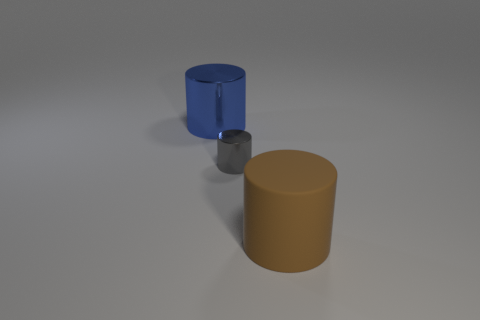Subtract all big cylinders. How many cylinders are left? 1 Add 1 gray metal objects. How many objects exist? 4 Subtract 2 cylinders. How many cylinders are left? 1 Subtract 1 gray cylinders. How many objects are left? 2 Subtract all gray cylinders. Subtract all cyan balls. How many cylinders are left? 2 Subtract all small brown matte balls. Subtract all tiny things. How many objects are left? 2 Add 3 gray metallic objects. How many gray metallic objects are left? 4 Add 3 large matte cylinders. How many large matte cylinders exist? 4 